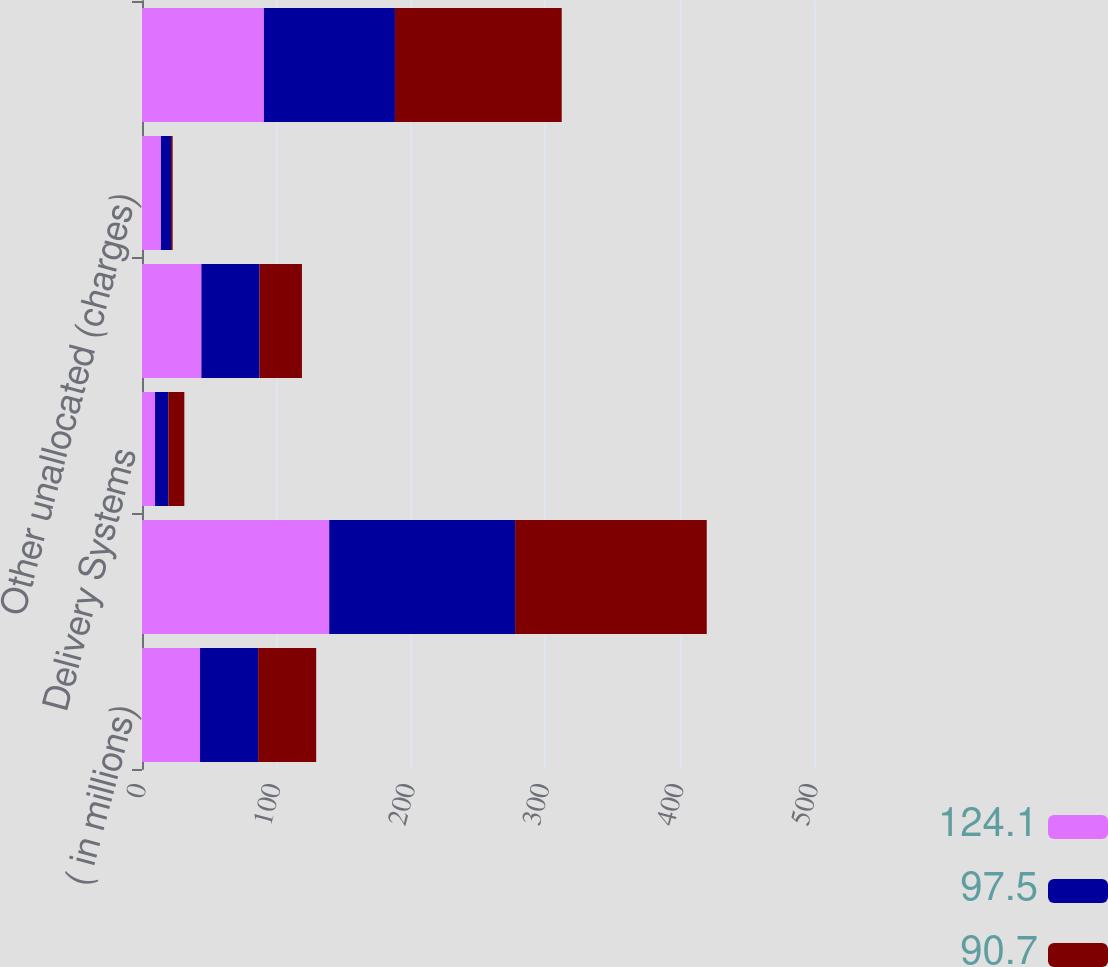Convert chart to OTSL. <chart><loc_0><loc_0><loc_500><loc_500><stacked_bar_chart><ecel><fcel>( in millions)<fcel>Packaging Systems<fcel>Delivery Systems<fcel>Corporate costs<fcel>Other unallocated (charges)<fcel>Consolidated Operating Profit<nl><fcel>124.1<fcel>43.2<fcel>139.3<fcel>9.7<fcel>44.2<fcel>14.1<fcel>90.7<nl><fcel>97.5<fcel>43.2<fcel>138.3<fcel>9.9<fcel>43.2<fcel>7.5<fcel>97.5<nl><fcel>90.7<fcel>43.2<fcel>142.6<fcel>11.9<fcel>31.6<fcel>1.2<fcel>124.1<nl></chart> 